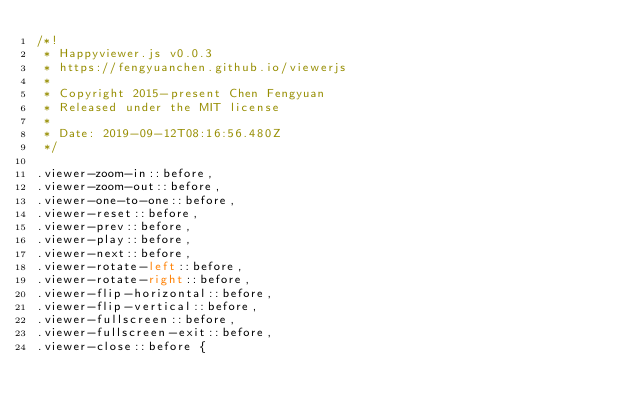Convert code to text. <code><loc_0><loc_0><loc_500><loc_500><_CSS_>/*!
 * Happyviewer.js v0.0.3
 * https://fengyuanchen.github.io/viewerjs
 *
 * Copyright 2015-present Chen Fengyuan
 * Released under the MIT license
 *
 * Date: 2019-09-12T08:16:56.480Z
 */

.viewer-zoom-in::before,
.viewer-zoom-out::before,
.viewer-one-to-one::before,
.viewer-reset::before,
.viewer-prev::before,
.viewer-play::before,
.viewer-next::before,
.viewer-rotate-left::before,
.viewer-rotate-right::before,
.viewer-flip-horizontal::before,
.viewer-flip-vertical::before,
.viewer-fullscreen::before,
.viewer-fullscreen-exit::before,
.viewer-close::before {</code> 